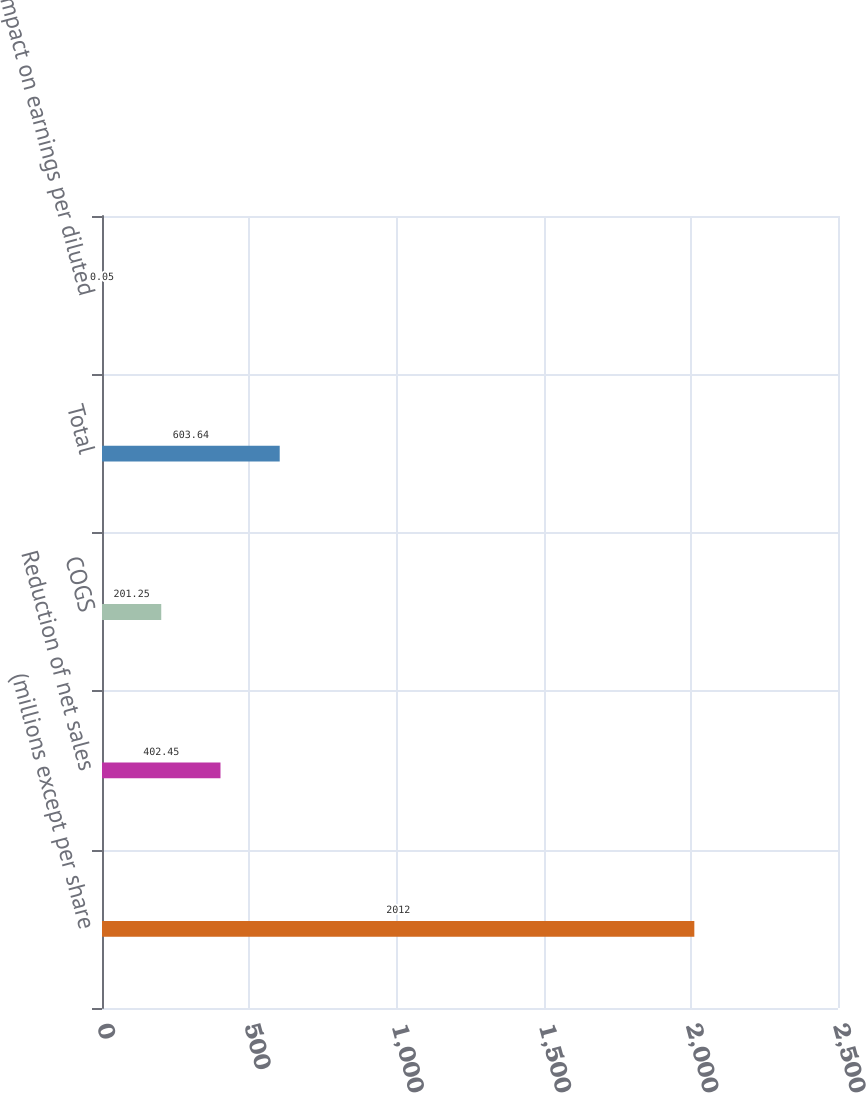<chart> <loc_0><loc_0><loc_500><loc_500><bar_chart><fcel>(millions except per share<fcel>Reduction of net sales<fcel>COGS<fcel>Total<fcel>Impact on earnings per diluted<nl><fcel>2012<fcel>402.45<fcel>201.25<fcel>603.64<fcel>0.05<nl></chart> 